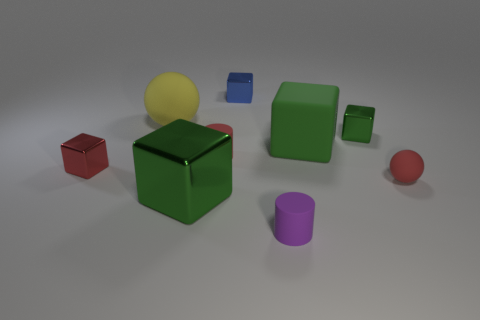Subtract all cyan cylinders. How many green cubes are left? 3 Subtract all blue blocks. How many blocks are left? 4 Subtract all yellow cubes. Subtract all gray cylinders. How many cubes are left? 5 Add 1 big blue metallic objects. How many objects exist? 10 Subtract all spheres. How many objects are left? 7 Add 5 tiny purple rubber objects. How many tiny purple rubber objects are left? 6 Add 2 purple rubber things. How many purple rubber things exist? 3 Subtract 0 green balls. How many objects are left? 9 Subtract all small blue things. Subtract all brown shiny cubes. How many objects are left? 8 